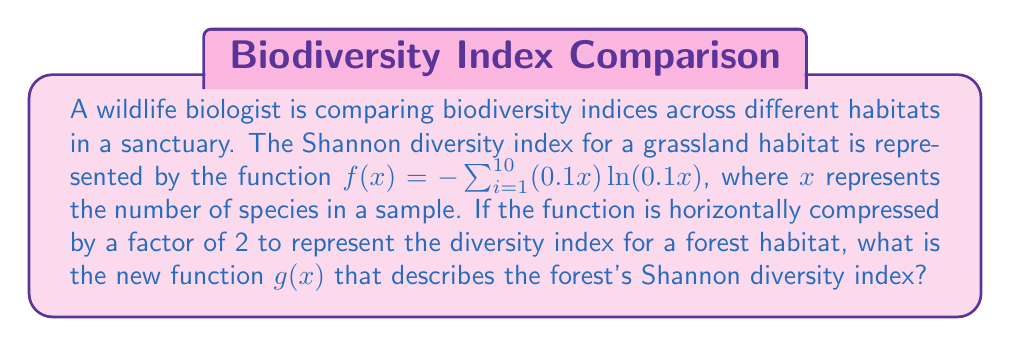Help me with this question. To solve this problem, we need to apply a horizontal compression to the given function. Here's how we do it step-by-step:

1) The original function for the grassland habitat is:
   $f(x) = -\sum_{i=1}^{10} (0.1x) \ln(0.1x)$

2) A horizontal compression by a factor of 2 means we replace every $x$ in the function with $(2x)$. This is because a horizontal compression makes the function "reach" its y-values twice as fast.

3) Replacing $x$ with $(2x)$ in the original function:
   $g(x) = -\sum_{i=1}^{10} (0.1(2x)) \ln(0.1(2x))$

4) Simplify the expression inside the parentheses:
   $g(x) = -\sum_{i=1}^{10} (0.2x) \ln(0.2x)$

5) This is our final compressed function representing the forest's Shannon diversity index.
Answer: $g(x) = -\sum_{i=1}^{10} (0.2x) \ln(0.2x)$ 